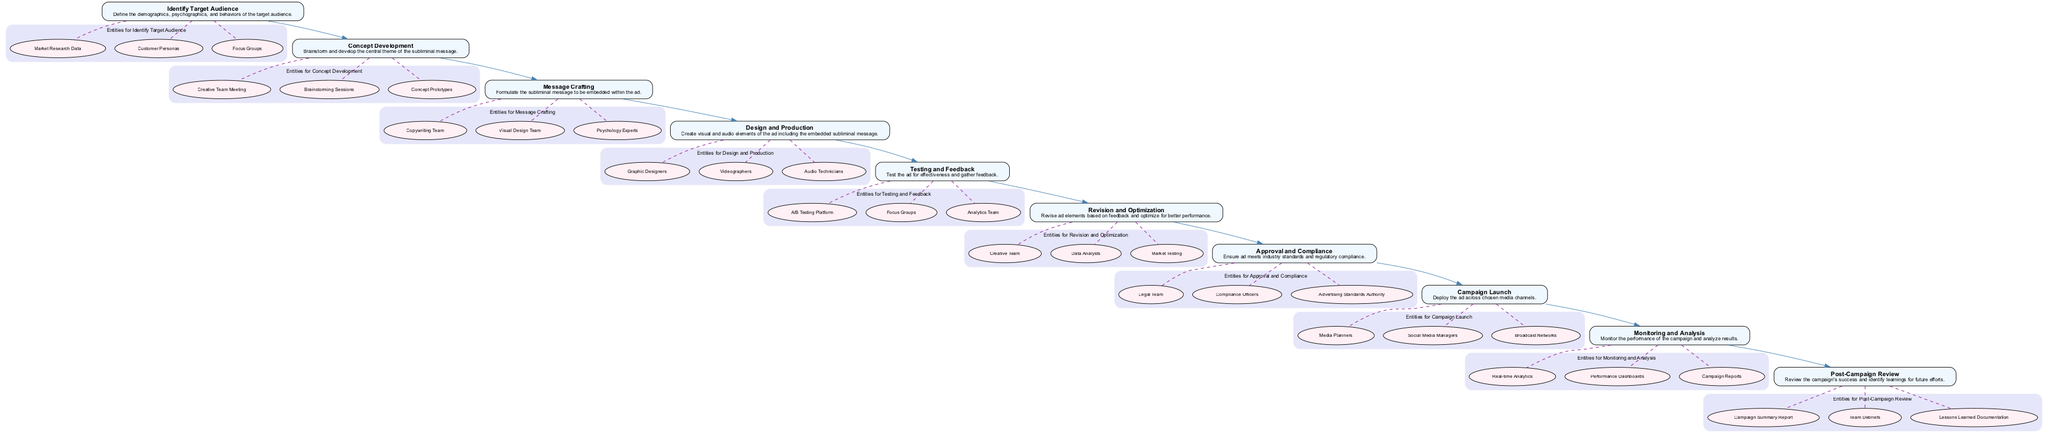What is the first step in the subliminal advertising campaign? The first step listed in the diagram is "Identify Target Audience," which appears at the top of the flowchart.
Answer: Identify Target Audience How many main steps are in the campaign process? By counting all the distinct nodes in the flowchart, there are ten main steps from "Identify Target Audience" to "Post-Campaign Review."
Answer: 10 Which step follows "Message Crafting"? After "Message Crafting," the next step in the flowchart is "Design and Production," which directly follows it sequentially.
Answer: Design and Production What is the purpose of the "Testing and Feedback" step? "Testing and Feedback" aims to assess the effectiveness of the ad and collect feedback, as described in the adjacent node.
Answer: Assess effectiveness and collect feedback Which entities are listed for "Concept Development"? The entities linked to "Concept Development" are "Creative Team Meeting," "Brainstorming Sessions," and "Concept Prototypes," as shown in the subgraph for that step.
Answer: Creative Team Meeting, Brainstorming Sessions, Concept Prototypes In which step do the legal and compliance check occur? The legal and compliance checks occur in the "Approval and Compliance" step, as specified in the flowchart.
Answer: Approval and Compliance What follows "Revision and Optimization"? The step that follows "Revision and Optimization" is "Approval and Compliance," indicating the flow in the campaign process.
Answer: Approval and Compliance How are the entities related to "Design and Production"? The entities related to "Design and Production" include "Graphic Designers," "Videographers," and "Audio Technicians," which are detailed in the entity cluster for that step.
Answer: Graphic Designers, Videographers, Audio Technicians What is the last step of the campaign process? The last step in the process, located at the end of the flowchart, is "Post-Campaign Review."
Answer: Post-Campaign Review How does "Monitoring and Analysis" relate to the overall campaign? "Monitoring and Analysis" is responsible for observing the performance and analyzing the results of the entire campaign, which is a vital component for future improvements.
Answer: Observing performance and analyzing results 